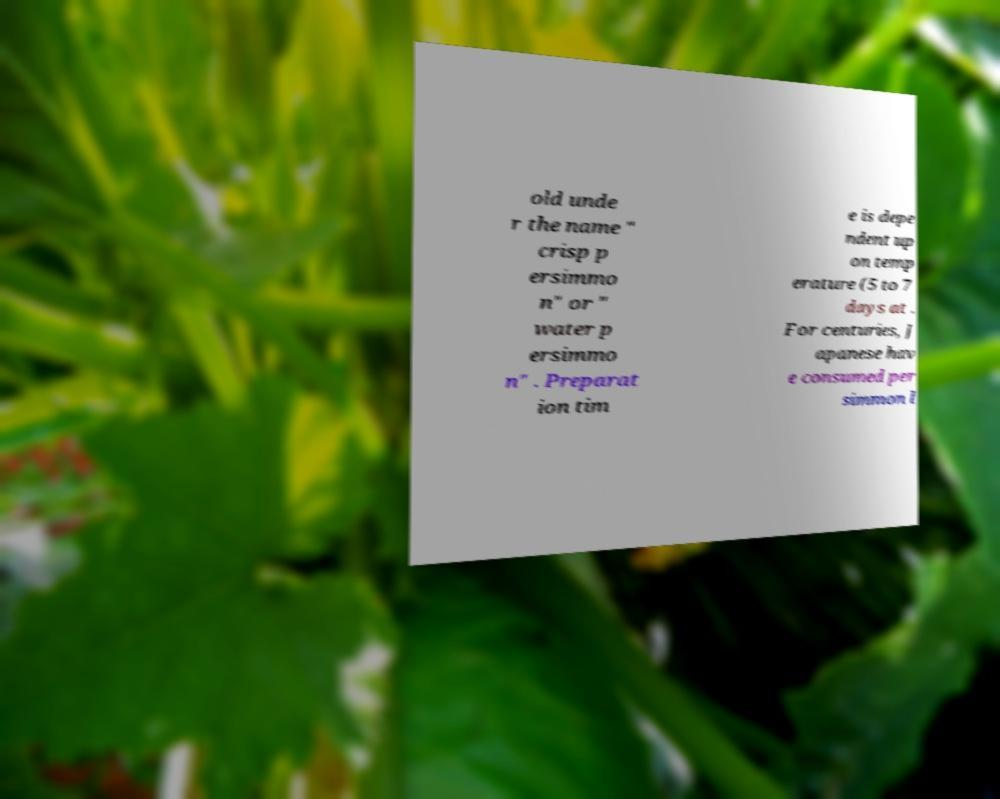Could you assist in decoding the text presented in this image and type it out clearly? old unde r the name " crisp p ersimmo n" or " water p ersimmo n" . Preparat ion tim e is depe ndent up on temp erature (5 to 7 days at . For centuries, J apanese hav e consumed per simmon l 